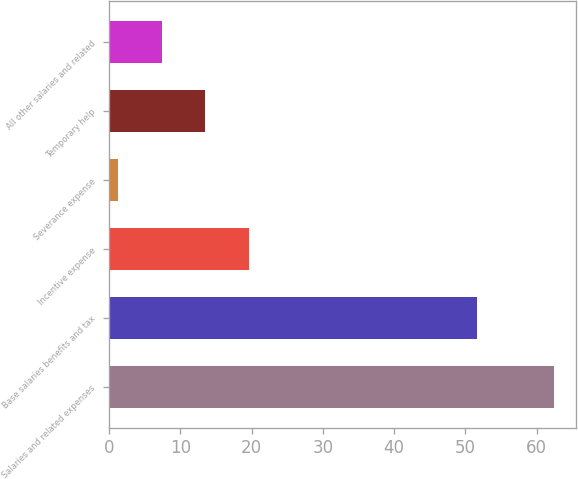Convert chart. <chart><loc_0><loc_0><loc_500><loc_500><bar_chart><fcel>Salaries and related expenses<fcel>Base salaries benefits and tax<fcel>Incentive expense<fcel>Severance expense<fcel>Temporary help<fcel>All other salaries and related<nl><fcel>62.4<fcel>51.6<fcel>19.63<fcel>1.3<fcel>13.52<fcel>7.41<nl></chart> 